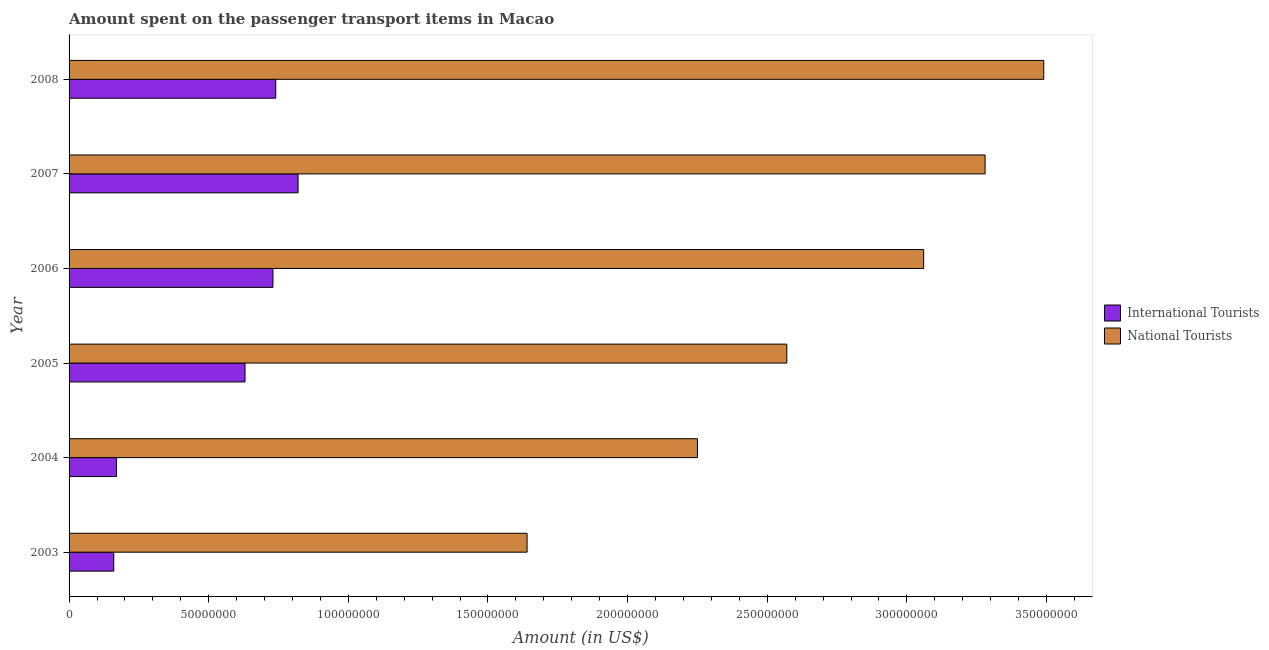How many groups of bars are there?
Your response must be concise. 6. Are the number of bars on each tick of the Y-axis equal?
Your answer should be very brief. Yes. In how many cases, is the number of bars for a given year not equal to the number of legend labels?
Your answer should be very brief. 0. What is the amount spent on transport items of national tourists in 2005?
Keep it short and to the point. 2.57e+08. Across all years, what is the maximum amount spent on transport items of international tourists?
Give a very brief answer. 8.20e+07. Across all years, what is the minimum amount spent on transport items of international tourists?
Your answer should be very brief. 1.60e+07. In which year was the amount spent on transport items of national tourists maximum?
Make the answer very short. 2008. In which year was the amount spent on transport items of international tourists minimum?
Ensure brevity in your answer.  2003. What is the total amount spent on transport items of national tourists in the graph?
Offer a very short reply. 1.63e+09. What is the difference between the amount spent on transport items of international tourists in 2004 and that in 2006?
Ensure brevity in your answer.  -5.60e+07. What is the difference between the amount spent on transport items of national tourists in 2008 and the amount spent on transport items of international tourists in 2003?
Make the answer very short. 3.33e+08. What is the average amount spent on transport items of national tourists per year?
Offer a terse response. 2.72e+08. In the year 2004, what is the difference between the amount spent on transport items of national tourists and amount spent on transport items of international tourists?
Offer a very short reply. 2.08e+08. In how many years, is the amount spent on transport items of national tourists greater than 330000000 US$?
Ensure brevity in your answer.  1. What is the ratio of the amount spent on transport items of international tourists in 2003 to that in 2008?
Provide a short and direct response. 0.22. What is the difference between the highest and the second highest amount spent on transport items of national tourists?
Your answer should be very brief. 2.10e+07. What is the difference between the highest and the lowest amount spent on transport items of national tourists?
Your answer should be compact. 1.85e+08. In how many years, is the amount spent on transport items of national tourists greater than the average amount spent on transport items of national tourists taken over all years?
Ensure brevity in your answer.  3. Is the sum of the amount spent on transport items of national tourists in 2003 and 2005 greater than the maximum amount spent on transport items of international tourists across all years?
Provide a short and direct response. Yes. What does the 2nd bar from the top in 2008 represents?
Keep it short and to the point. International Tourists. What does the 2nd bar from the bottom in 2007 represents?
Ensure brevity in your answer.  National Tourists. How many bars are there?
Keep it short and to the point. 12. Are all the bars in the graph horizontal?
Ensure brevity in your answer.  Yes. What is the difference between two consecutive major ticks on the X-axis?
Provide a succinct answer. 5.00e+07. Where does the legend appear in the graph?
Provide a short and direct response. Center right. How are the legend labels stacked?
Your response must be concise. Vertical. What is the title of the graph?
Ensure brevity in your answer.  Amount spent on the passenger transport items in Macao. Does "Adolescent fertility rate" appear as one of the legend labels in the graph?
Give a very brief answer. No. What is the label or title of the X-axis?
Keep it short and to the point. Amount (in US$). What is the Amount (in US$) of International Tourists in 2003?
Provide a succinct answer. 1.60e+07. What is the Amount (in US$) in National Tourists in 2003?
Offer a very short reply. 1.64e+08. What is the Amount (in US$) in International Tourists in 2004?
Keep it short and to the point. 1.70e+07. What is the Amount (in US$) of National Tourists in 2004?
Your response must be concise. 2.25e+08. What is the Amount (in US$) of International Tourists in 2005?
Keep it short and to the point. 6.30e+07. What is the Amount (in US$) of National Tourists in 2005?
Make the answer very short. 2.57e+08. What is the Amount (in US$) in International Tourists in 2006?
Your answer should be compact. 7.30e+07. What is the Amount (in US$) of National Tourists in 2006?
Keep it short and to the point. 3.06e+08. What is the Amount (in US$) in International Tourists in 2007?
Provide a succinct answer. 8.20e+07. What is the Amount (in US$) of National Tourists in 2007?
Your response must be concise. 3.28e+08. What is the Amount (in US$) in International Tourists in 2008?
Keep it short and to the point. 7.40e+07. What is the Amount (in US$) of National Tourists in 2008?
Offer a very short reply. 3.49e+08. Across all years, what is the maximum Amount (in US$) in International Tourists?
Offer a terse response. 8.20e+07. Across all years, what is the maximum Amount (in US$) in National Tourists?
Offer a very short reply. 3.49e+08. Across all years, what is the minimum Amount (in US$) of International Tourists?
Ensure brevity in your answer.  1.60e+07. Across all years, what is the minimum Amount (in US$) in National Tourists?
Your answer should be compact. 1.64e+08. What is the total Amount (in US$) of International Tourists in the graph?
Provide a succinct answer. 3.25e+08. What is the total Amount (in US$) in National Tourists in the graph?
Make the answer very short. 1.63e+09. What is the difference between the Amount (in US$) of International Tourists in 2003 and that in 2004?
Offer a terse response. -1.00e+06. What is the difference between the Amount (in US$) of National Tourists in 2003 and that in 2004?
Ensure brevity in your answer.  -6.10e+07. What is the difference between the Amount (in US$) in International Tourists in 2003 and that in 2005?
Make the answer very short. -4.70e+07. What is the difference between the Amount (in US$) in National Tourists in 2003 and that in 2005?
Make the answer very short. -9.30e+07. What is the difference between the Amount (in US$) of International Tourists in 2003 and that in 2006?
Make the answer very short. -5.70e+07. What is the difference between the Amount (in US$) in National Tourists in 2003 and that in 2006?
Your answer should be compact. -1.42e+08. What is the difference between the Amount (in US$) in International Tourists in 2003 and that in 2007?
Your answer should be very brief. -6.60e+07. What is the difference between the Amount (in US$) of National Tourists in 2003 and that in 2007?
Provide a succinct answer. -1.64e+08. What is the difference between the Amount (in US$) of International Tourists in 2003 and that in 2008?
Your answer should be very brief. -5.80e+07. What is the difference between the Amount (in US$) in National Tourists in 2003 and that in 2008?
Your answer should be very brief. -1.85e+08. What is the difference between the Amount (in US$) of International Tourists in 2004 and that in 2005?
Offer a terse response. -4.60e+07. What is the difference between the Amount (in US$) of National Tourists in 2004 and that in 2005?
Your answer should be compact. -3.20e+07. What is the difference between the Amount (in US$) in International Tourists in 2004 and that in 2006?
Provide a short and direct response. -5.60e+07. What is the difference between the Amount (in US$) in National Tourists in 2004 and that in 2006?
Ensure brevity in your answer.  -8.10e+07. What is the difference between the Amount (in US$) in International Tourists in 2004 and that in 2007?
Your answer should be compact. -6.50e+07. What is the difference between the Amount (in US$) in National Tourists in 2004 and that in 2007?
Ensure brevity in your answer.  -1.03e+08. What is the difference between the Amount (in US$) in International Tourists in 2004 and that in 2008?
Offer a very short reply. -5.70e+07. What is the difference between the Amount (in US$) in National Tourists in 2004 and that in 2008?
Offer a very short reply. -1.24e+08. What is the difference between the Amount (in US$) in International Tourists in 2005 and that in 2006?
Provide a succinct answer. -1.00e+07. What is the difference between the Amount (in US$) in National Tourists in 2005 and that in 2006?
Provide a succinct answer. -4.90e+07. What is the difference between the Amount (in US$) in International Tourists in 2005 and that in 2007?
Keep it short and to the point. -1.90e+07. What is the difference between the Amount (in US$) in National Tourists in 2005 and that in 2007?
Keep it short and to the point. -7.10e+07. What is the difference between the Amount (in US$) of International Tourists in 2005 and that in 2008?
Your answer should be compact. -1.10e+07. What is the difference between the Amount (in US$) of National Tourists in 2005 and that in 2008?
Your response must be concise. -9.20e+07. What is the difference between the Amount (in US$) of International Tourists in 2006 and that in 2007?
Your answer should be compact. -9.00e+06. What is the difference between the Amount (in US$) of National Tourists in 2006 and that in 2007?
Give a very brief answer. -2.20e+07. What is the difference between the Amount (in US$) of International Tourists in 2006 and that in 2008?
Provide a short and direct response. -1.00e+06. What is the difference between the Amount (in US$) of National Tourists in 2006 and that in 2008?
Provide a succinct answer. -4.30e+07. What is the difference between the Amount (in US$) of National Tourists in 2007 and that in 2008?
Keep it short and to the point. -2.10e+07. What is the difference between the Amount (in US$) in International Tourists in 2003 and the Amount (in US$) in National Tourists in 2004?
Make the answer very short. -2.09e+08. What is the difference between the Amount (in US$) of International Tourists in 2003 and the Amount (in US$) of National Tourists in 2005?
Offer a terse response. -2.41e+08. What is the difference between the Amount (in US$) of International Tourists in 2003 and the Amount (in US$) of National Tourists in 2006?
Keep it short and to the point. -2.90e+08. What is the difference between the Amount (in US$) in International Tourists in 2003 and the Amount (in US$) in National Tourists in 2007?
Keep it short and to the point. -3.12e+08. What is the difference between the Amount (in US$) of International Tourists in 2003 and the Amount (in US$) of National Tourists in 2008?
Ensure brevity in your answer.  -3.33e+08. What is the difference between the Amount (in US$) of International Tourists in 2004 and the Amount (in US$) of National Tourists in 2005?
Offer a very short reply. -2.40e+08. What is the difference between the Amount (in US$) in International Tourists in 2004 and the Amount (in US$) in National Tourists in 2006?
Provide a short and direct response. -2.89e+08. What is the difference between the Amount (in US$) of International Tourists in 2004 and the Amount (in US$) of National Tourists in 2007?
Give a very brief answer. -3.11e+08. What is the difference between the Amount (in US$) in International Tourists in 2004 and the Amount (in US$) in National Tourists in 2008?
Provide a succinct answer. -3.32e+08. What is the difference between the Amount (in US$) in International Tourists in 2005 and the Amount (in US$) in National Tourists in 2006?
Offer a terse response. -2.43e+08. What is the difference between the Amount (in US$) of International Tourists in 2005 and the Amount (in US$) of National Tourists in 2007?
Your answer should be compact. -2.65e+08. What is the difference between the Amount (in US$) in International Tourists in 2005 and the Amount (in US$) in National Tourists in 2008?
Provide a succinct answer. -2.86e+08. What is the difference between the Amount (in US$) of International Tourists in 2006 and the Amount (in US$) of National Tourists in 2007?
Offer a terse response. -2.55e+08. What is the difference between the Amount (in US$) in International Tourists in 2006 and the Amount (in US$) in National Tourists in 2008?
Provide a succinct answer. -2.76e+08. What is the difference between the Amount (in US$) in International Tourists in 2007 and the Amount (in US$) in National Tourists in 2008?
Offer a very short reply. -2.67e+08. What is the average Amount (in US$) in International Tourists per year?
Offer a terse response. 5.42e+07. What is the average Amount (in US$) in National Tourists per year?
Provide a succinct answer. 2.72e+08. In the year 2003, what is the difference between the Amount (in US$) of International Tourists and Amount (in US$) of National Tourists?
Your answer should be very brief. -1.48e+08. In the year 2004, what is the difference between the Amount (in US$) in International Tourists and Amount (in US$) in National Tourists?
Offer a very short reply. -2.08e+08. In the year 2005, what is the difference between the Amount (in US$) of International Tourists and Amount (in US$) of National Tourists?
Provide a short and direct response. -1.94e+08. In the year 2006, what is the difference between the Amount (in US$) of International Tourists and Amount (in US$) of National Tourists?
Provide a succinct answer. -2.33e+08. In the year 2007, what is the difference between the Amount (in US$) of International Tourists and Amount (in US$) of National Tourists?
Your answer should be very brief. -2.46e+08. In the year 2008, what is the difference between the Amount (in US$) of International Tourists and Amount (in US$) of National Tourists?
Your answer should be very brief. -2.75e+08. What is the ratio of the Amount (in US$) of National Tourists in 2003 to that in 2004?
Your answer should be compact. 0.73. What is the ratio of the Amount (in US$) of International Tourists in 2003 to that in 2005?
Your answer should be very brief. 0.25. What is the ratio of the Amount (in US$) in National Tourists in 2003 to that in 2005?
Provide a succinct answer. 0.64. What is the ratio of the Amount (in US$) in International Tourists in 2003 to that in 2006?
Offer a very short reply. 0.22. What is the ratio of the Amount (in US$) in National Tourists in 2003 to that in 2006?
Make the answer very short. 0.54. What is the ratio of the Amount (in US$) in International Tourists in 2003 to that in 2007?
Ensure brevity in your answer.  0.2. What is the ratio of the Amount (in US$) of National Tourists in 2003 to that in 2007?
Your response must be concise. 0.5. What is the ratio of the Amount (in US$) of International Tourists in 2003 to that in 2008?
Offer a terse response. 0.22. What is the ratio of the Amount (in US$) of National Tourists in 2003 to that in 2008?
Provide a succinct answer. 0.47. What is the ratio of the Amount (in US$) in International Tourists in 2004 to that in 2005?
Your response must be concise. 0.27. What is the ratio of the Amount (in US$) of National Tourists in 2004 to that in 2005?
Provide a short and direct response. 0.88. What is the ratio of the Amount (in US$) of International Tourists in 2004 to that in 2006?
Provide a succinct answer. 0.23. What is the ratio of the Amount (in US$) of National Tourists in 2004 to that in 2006?
Your answer should be very brief. 0.74. What is the ratio of the Amount (in US$) of International Tourists in 2004 to that in 2007?
Give a very brief answer. 0.21. What is the ratio of the Amount (in US$) in National Tourists in 2004 to that in 2007?
Provide a succinct answer. 0.69. What is the ratio of the Amount (in US$) in International Tourists in 2004 to that in 2008?
Ensure brevity in your answer.  0.23. What is the ratio of the Amount (in US$) in National Tourists in 2004 to that in 2008?
Your response must be concise. 0.64. What is the ratio of the Amount (in US$) of International Tourists in 2005 to that in 2006?
Provide a succinct answer. 0.86. What is the ratio of the Amount (in US$) of National Tourists in 2005 to that in 2006?
Offer a terse response. 0.84. What is the ratio of the Amount (in US$) in International Tourists in 2005 to that in 2007?
Provide a short and direct response. 0.77. What is the ratio of the Amount (in US$) of National Tourists in 2005 to that in 2007?
Your response must be concise. 0.78. What is the ratio of the Amount (in US$) of International Tourists in 2005 to that in 2008?
Make the answer very short. 0.85. What is the ratio of the Amount (in US$) of National Tourists in 2005 to that in 2008?
Your answer should be very brief. 0.74. What is the ratio of the Amount (in US$) in International Tourists in 2006 to that in 2007?
Your response must be concise. 0.89. What is the ratio of the Amount (in US$) in National Tourists in 2006 to that in 2007?
Make the answer very short. 0.93. What is the ratio of the Amount (in US$) in International Tourists in 2006 to that in 2008?
Keep it short and to the point. 0.99. What is the ratio of the Amount (in US$) in National Tourists in 2006 to that in 2008?
Your response must be concise. 0.88. What is the ratio of the Amount (in US$) in International Tourists in 2007 to that in 2008?
Provide a short and direct response. 1.11. What is the ratio of the Amount (in US$) in National Tourists in 2007 to that in 2008?
Your answer should be very brief. 0.94. What is the difference between the highest and the second highest Amount (in US$) in International Tourists?
Your response must be concise. 8.00e+06. What is the difference between the highest and the second highest Amount (in US$) in National Tourists?
Give a very brief answer. 2.10e+07. What is the difference between the highest and the lowest Amount (in US$) in International Tourists?
Your response must be concise. 6.60e+07. What is the difference between the highest and the lowest Amount (in US$) of National Tourists?
Provide a succinct answer. 1.85e+08. 